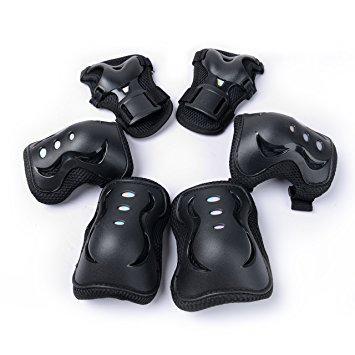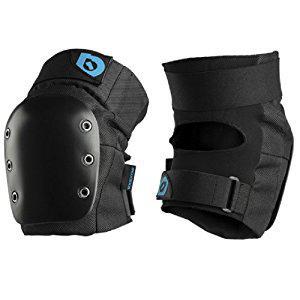The first image is the image on the left, the second image is the image on the right. For the images displayed, is the sentence "there are 6 kneepads per image pair" factually correct? Answer yes or no. No. The first image is the image on the left, the second image is the image on the right. Analyze the images presented: Is the assertion "There are exactly six pads in total." valid? Answer yes or no. No. 